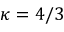<formula> <loc_0><loc_0><loc_500><loc_500>\kappa = 4 / 3</formula> 